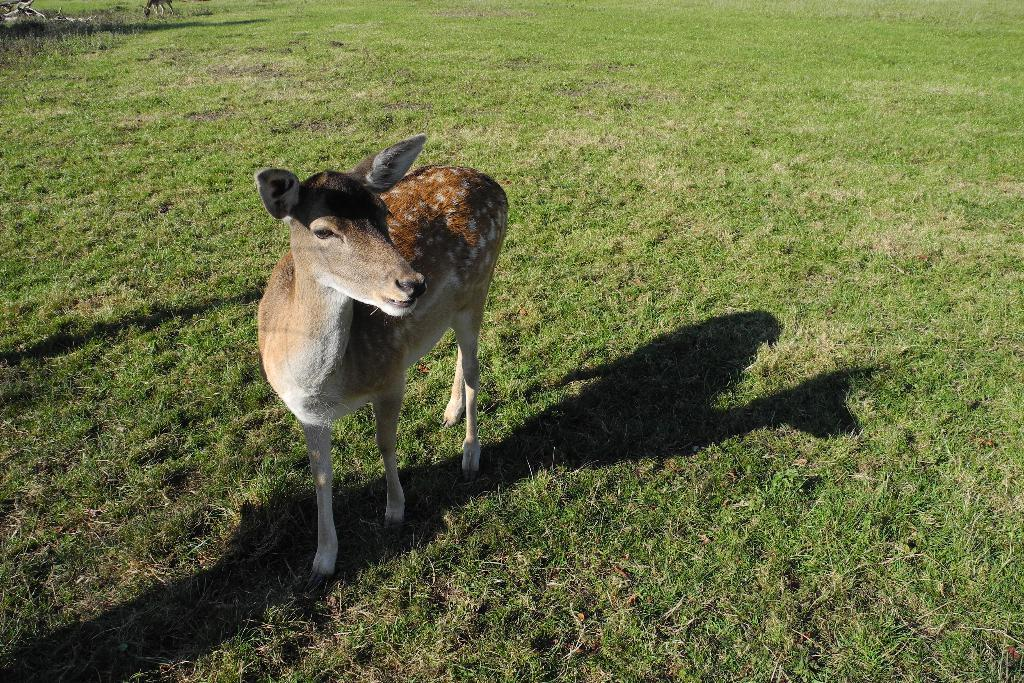What type of animal can be seen in the image? There is a deer in the image. What is the deer doing in the image? The deer is standing on the ground. What type of vegetation is visible in the image? There is green grass visible in the image. What other animal can be seen in the image? There is another animal in the image. What object is present in the image? There is a stick in the image. How many apples are being held by the deer in the image? There are no apples present in the image; the deer is not holding any apples. 